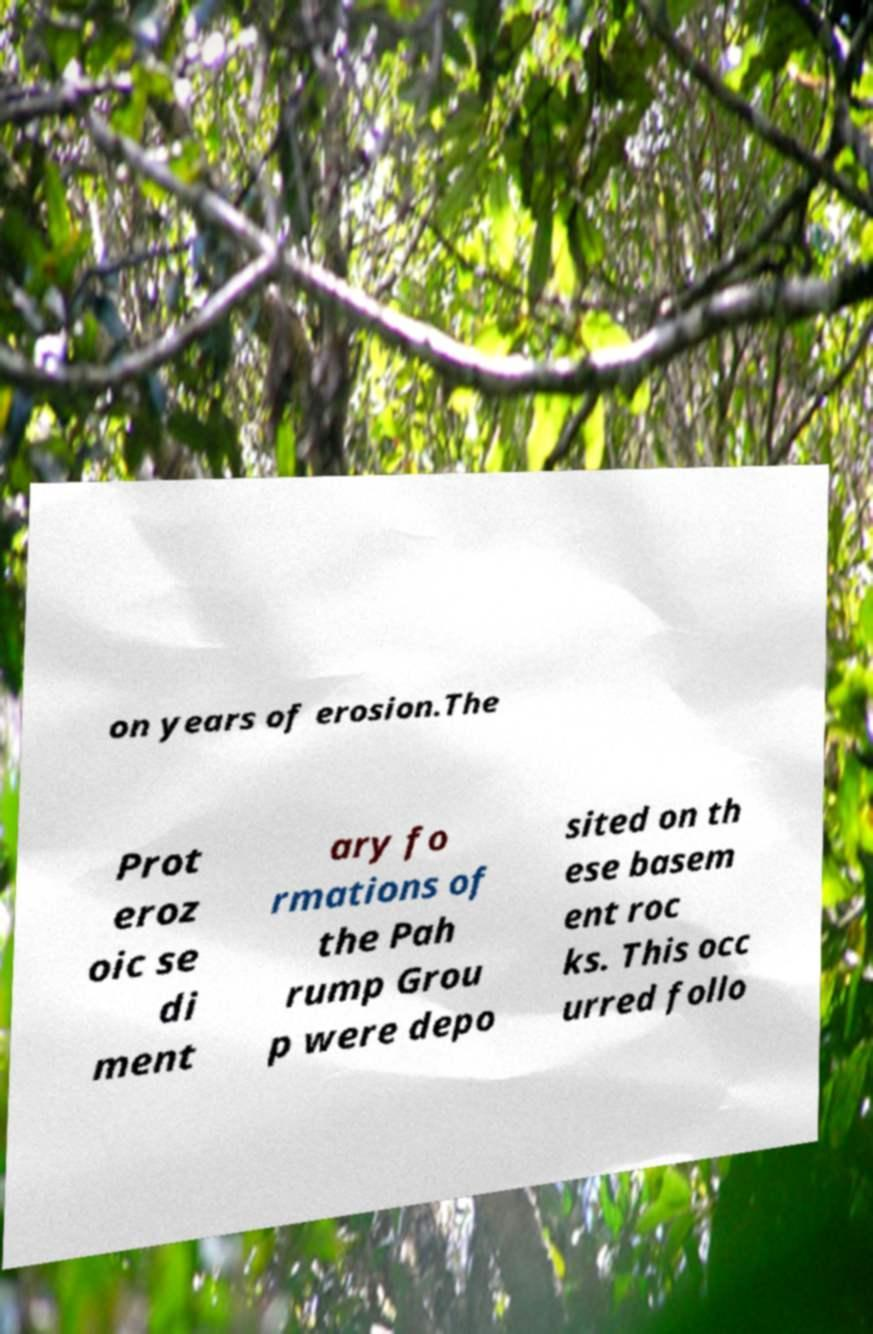For documentation purposes, I need the text within this image transcribed. Could you provide that? on years of erosion.The Prot eroz oic se di ment ary fo rmations of the Pah rump Grou p were depo sited on th ese basem ent roc ks. This occ urred follo 